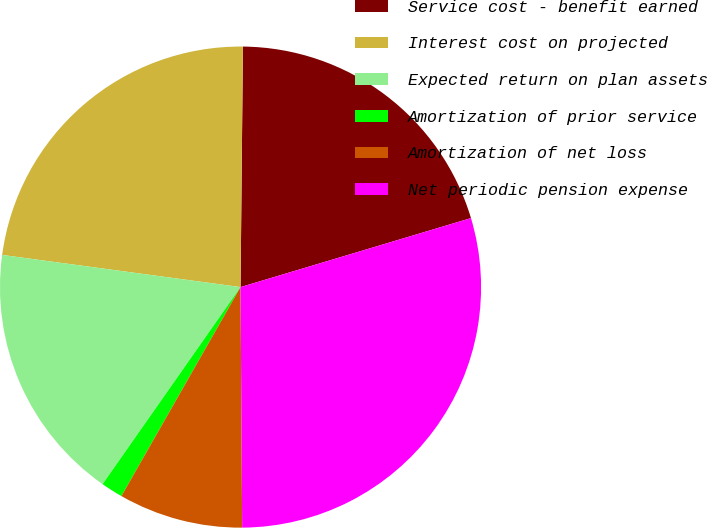Convert chart to OTSL. <chart><loc_0><loc_0><loc_500><loc_500><pie_chart><fcel>Service cost - benefit earned<fcel>Interest cost on projected<fcel>Expected return on plan assets<fcel>Amortization of prior service<fcel>Amortization of net loss<fcel>Net periodic pension expense<nl><fcel>20.21%<fcel>23.02%<fcel>17.41%<fcel>1.48%<fcel>8.35%<fcel>29.52%<nl></chart> 